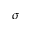<formula> <loc_0><loc_0><loc_500><loc_500>\sigma</formula> 